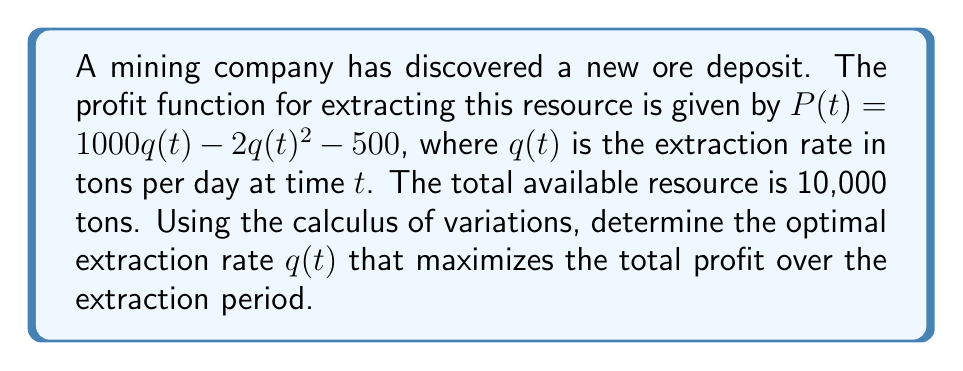Could you help me with this problem? To solve this problem, we'll use the Euler-Lagrange equation from the calculus of variations:

1) First, we define the functional to be maximized:
   $$J[q] = \int_0^T (1000q - 2q^2 - 500) dt$$
   where $T$ is the unknown final time.

2) We have the constraint:
   $$\int_0^T q(t) dt = 10000$$

3) Form the augmented functional with Lagrange multiplier $\lambda$:
   $$J[q] = \int_0^T (1000q - 2q^2 - 500 - \lambda q) dt$$

4) The Euler-Lagrange equation is:
   $$\frac{\partial F}{\partial q} - \frac{d}{dt}\frac{\partial F}{\partial \dot{q}} = 0$$
   where $F = 1000q - 2q^2 - 500 - \lambda q$

5) Applying the equation:
   $$1000 - 4q - \lambda = 0$$

6) Solving for $q$:
   $$q(t) = 250 - \frac{\lambda}{4}$$

7) Using the constraint:
   $$\int_0^T (250 - \frac{\lambda}{4}) dt = 10000$$
   $$(250 - \frac{\lambda}{4})T = 10000$$

8) Solving for $T$:
   $$T = \frac{40000}{1000 - \lambda}$$

9) The optimal extraction rate is constant over time:
   $$q^*(t) = 250 - \frac{\lambda}{4} = \frac{10000}{T} = 100$$

10) Therefore, $\lambda = 600$ and $T = 100$ days.
Answer: $q^*(t) = 100$ tons/day 